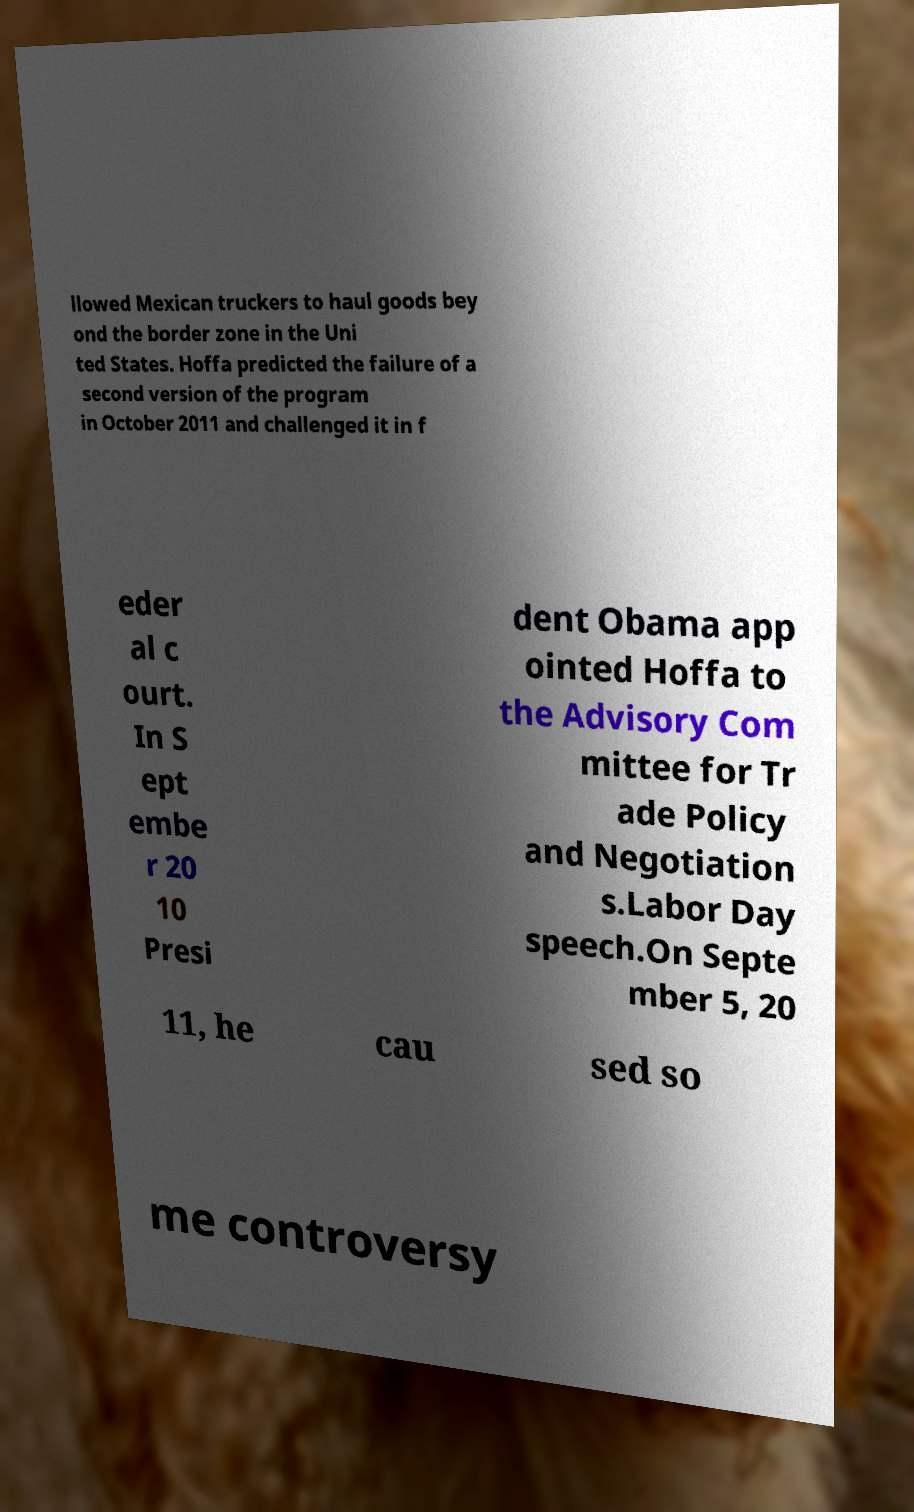Please identify and transcribe the text found in this image. llowed Mexican truckers to haul goods bey ond the border zone in the Uni ted States. Hoffa predicted the failure of a second version of the program in October 2011 and challenged it in f eder al c ourt. In S ept embe r 20 10 Presi dent Obama app ointed Hoffa to the Advisory Com mittee for Tr ade Policy and Negotiation s.Labor Day speech.On Septe mber 5, 20 11, he cau sed so me controversy 